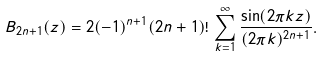<formula> <loc_0><loc_0><loc_500><loc_500>B _ { 2 n + 1 } ( z ) = 2 ( - 1 ) ^ { n + 1 } ( 2 n + 1 ) ! \, \sum _ { k = 1 } ^ { \infty } \frac { \sin ( 2 \pi k z ) } { ( 2 \pi k ) ^ { 2 n + 1 } } .</formula> 